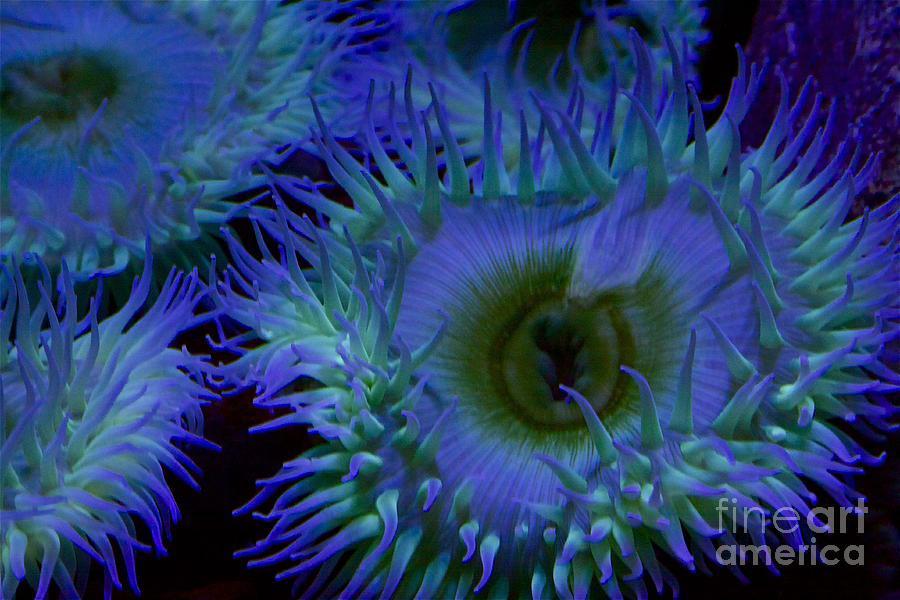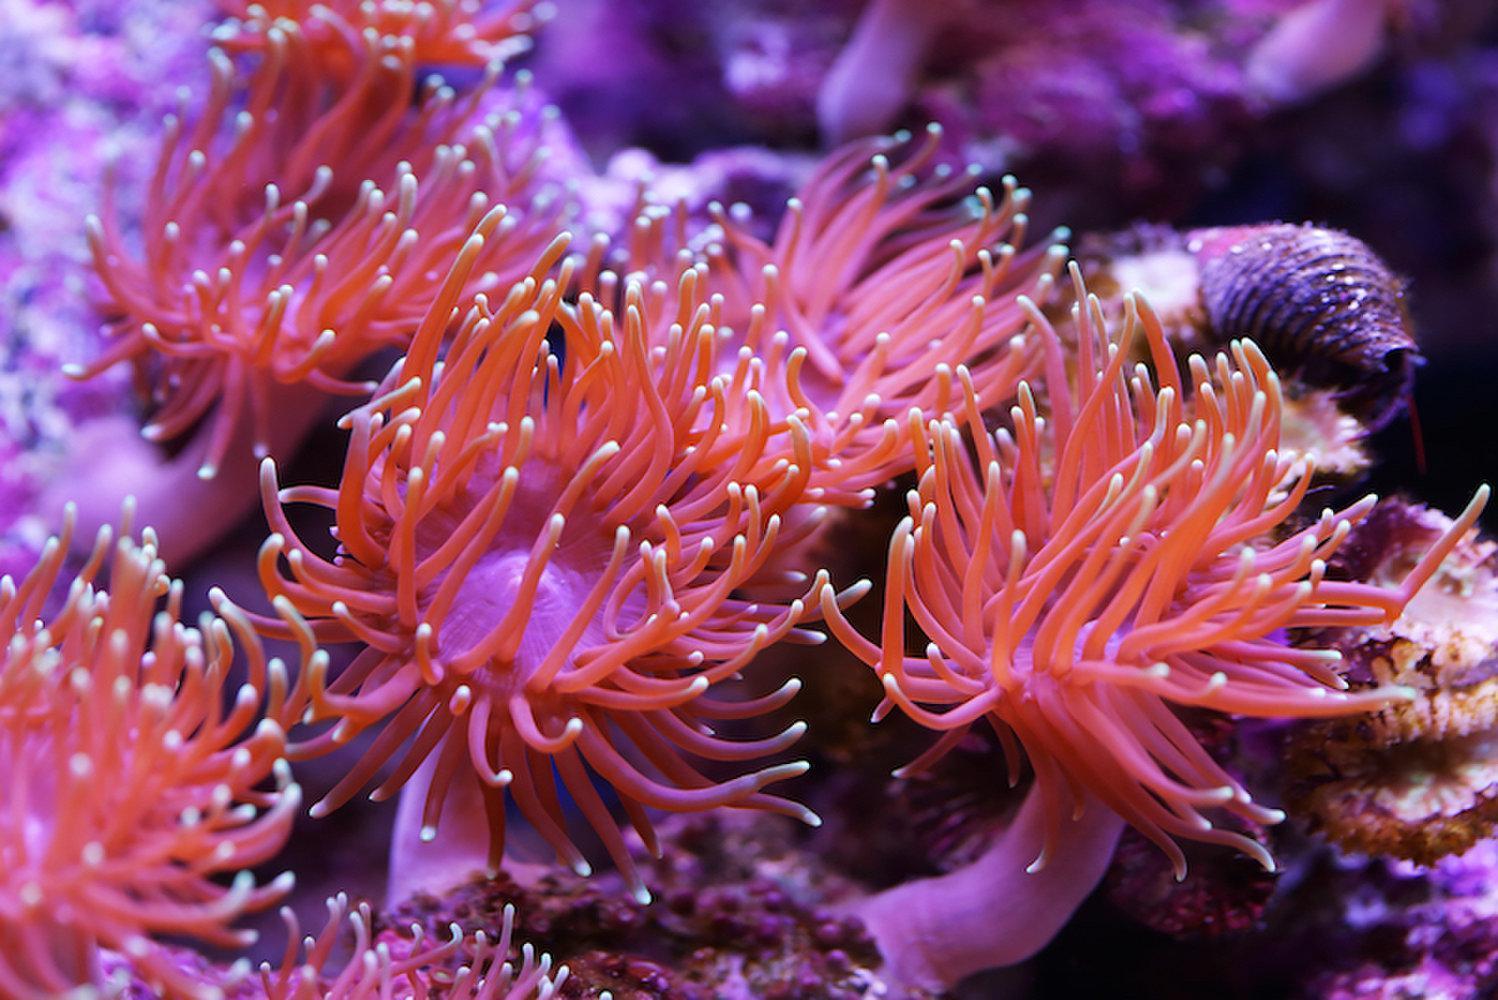The first image is the image on the left, the second image is the image on the right. For the images displayed, is the sentence "There is a pink Sea anemone in the right image." factually correct? Answer yes or no. Yes. The first image is the image on the left, the second image is the image on the right. Given the left and right images, does the statement "At least one image shows a striped clown fish swimming among anemone tendrils." hold true? Answer yes or no. No. 